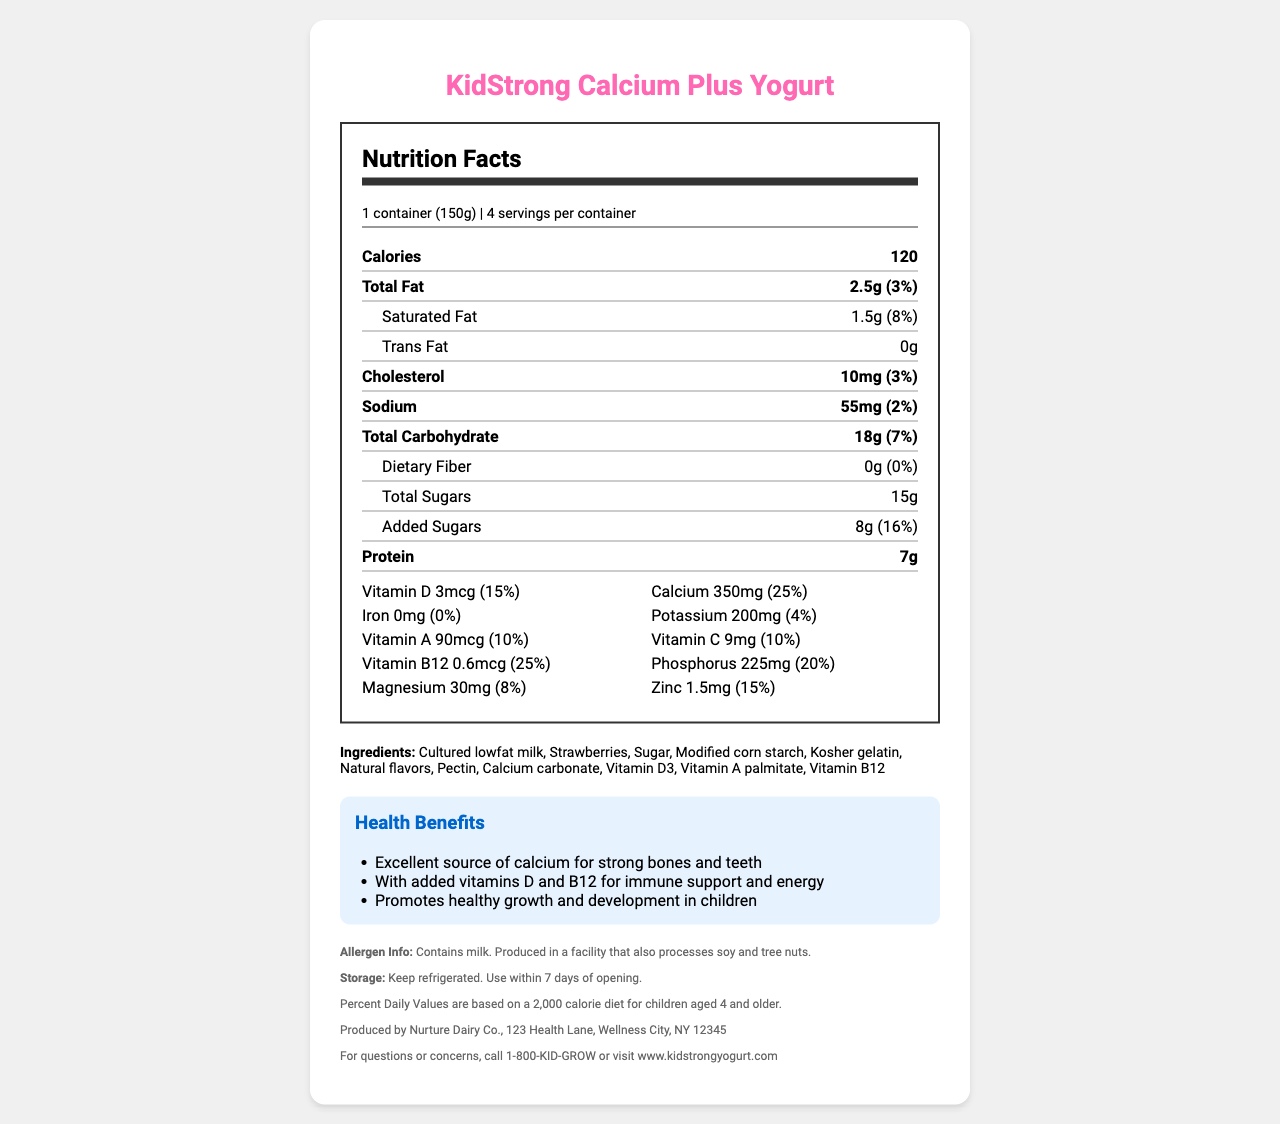what is the product name? The product name is displayed at the top of the document.
Answer: KidStrong Calcium Plus Yogurt what is the serving size of KidStrong Calcium Plus Yogurt? The serving size is mentioned under the "Nutrition Facts" section.
Answer: 1 container (150g) how many servings are there per container? The number of servings per container is stated alongside the serving size.
Answer: 4 what is the calorie content per serving? The calorie content is shown prominently in the "Nutrition Facts" section.
Answer: 120 calories how much protein does each serving provide? The protein content is listed in the "Nutrition Facts" section.
Answer: 7g what is the daily value percentage of calcium in KidStrong Calcium Plus Yogurt? The daily value percentage of calcium is clearly stated in the "Nutrition Facts" section under the vitamins section.
Answer: 25% what is the main source of calcium mentioned in the ingredients? Calcium carbonate is listed among the ingredients.
Answer: Calcium carbonate What is the amount of total fat per serving? The total fat content is listed in the "Nutrition Facts" section.
Answer: 2.5g What are the total carbohydrates per serving? A) 18g B) 25g C) 7g D) 5g The "Nutrition Facts" section states that the total carbohydrate content per serving is 18g.
Answer: A) 18g How much Vitamin D does one serving provide? A) 5mcg B) 3mcg C) 9mcg D) 0mcg The "Nutrition Facts" section indicates that one serving provides 3mcg of Vitamin D.
Answer: B) 3mcg Does this product contain any fiber? The "Nutrition Facts" section shows that the dietary fiber is 0g.
Answer: No What is the primary health claim made by the product? This health claim is listed under the "Health Benefits" section.
Answer: Excellent source of calcium for strong bones and teeth Is this product suitable for people with tree nut allergies? The allergen info indicates that the product is produced in a facility that also processes tree nuts.
Answer: No Summarize the main nutrients and health claims of KidStrong Calcium Plus Yogurt. The summary covers the nutrient content and the health claims mentioned in the document.
Answer: KidStrong Calcium Plus Yogurt is a dairy product offering key nutrients like 7g protein, 120 calories, 350mg calcium (25% DV), 18g total carbohydrates, and added vitamins D and B12. It promotes strong bones and teeth, supports immune function, and healthy growth in children. Can this product help in reducing dietary cholesterol? The document does not provide information on whether the product helps in reducing dietary cholesterol. The only information provided is the cholesterol content per serving.
Answer: Cannot be determined 